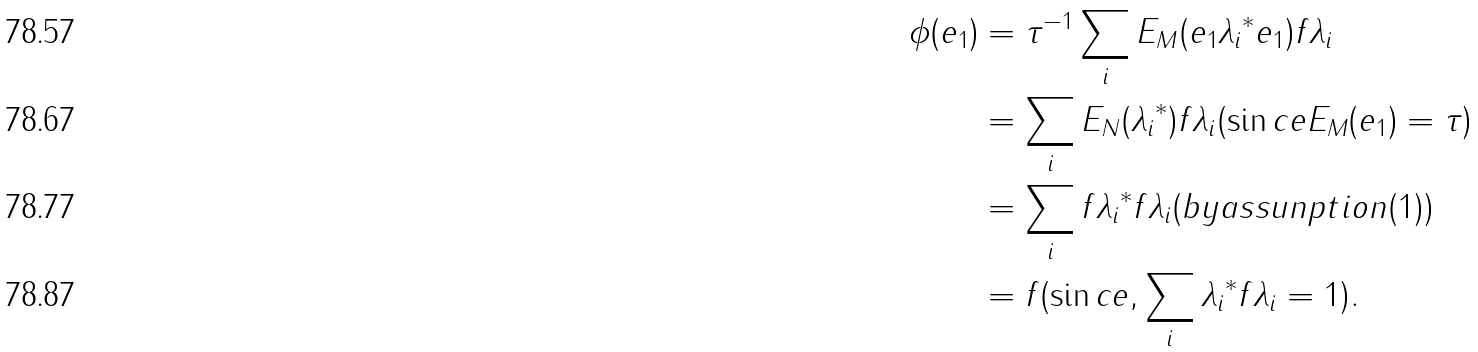Convert formula to latex. <formula><loc_0><loc_0><loc_500><loc_500>\phi ( e _ { 1 } ) & = { \tau } ^ { - 1 } \sum _ { i } E _ { M } ( e _ { 1 } { \lambda _ { i } } ^ { * } e _ { 1 } ) f { \lambda _ { i } } \\ & = \sum _ { i } E _ { N } ( { \lambda _ { i } } ^ { * } ) f \lambda _ { i } ( \sin c e E _ { M } ( e _ { 1 } ) = \tau ) \\ & = \sum _ { i } f { \lambda _ { i } } ^ { * } f \lambda _ { i } ( b y a s s u n p t i o n ( 1 ) ) \\ & = f ( \sin c e , \sum _ { i } { \lambda _ { i } } ^ { * } f { \lambda _ { i } } = 1 ) .</formula> 